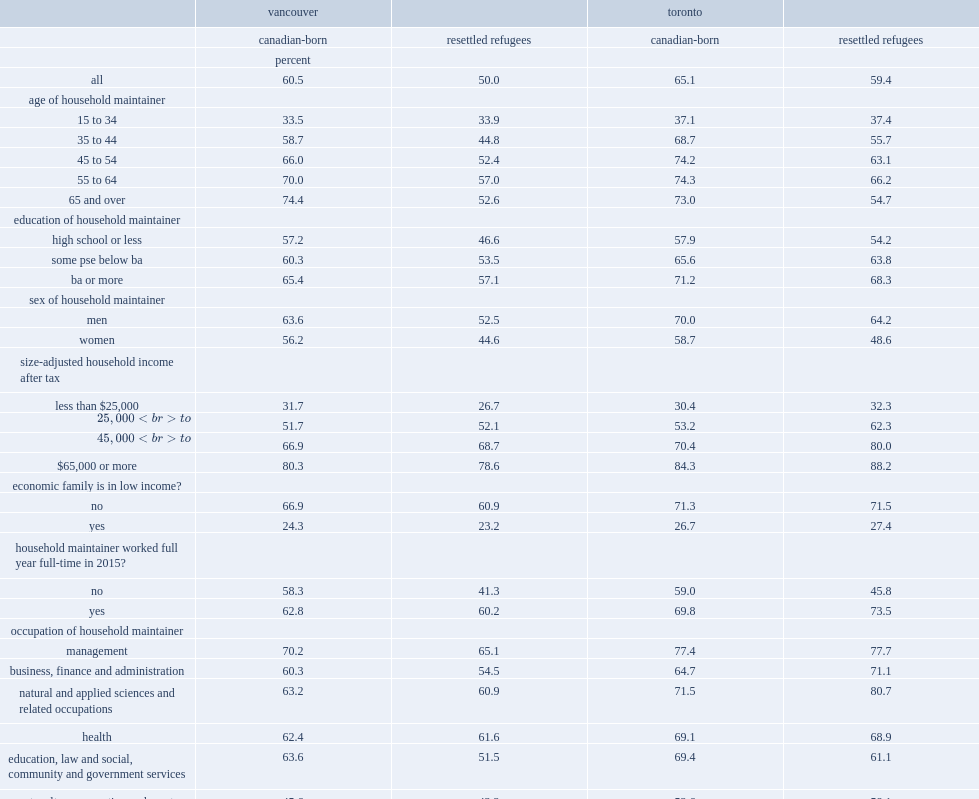Which group has the lower rates of homeownership in toronto, resettled refugee families or canadian-born families? Resettled refugees. Which group has the lower rates of homeownership in vancouver, resettled refugee families or canadian-born families? Resettled refugees. What was the percentage of refugee families that owned residential property in vancouver in 2016? 50. What was the percentage of canadian-born families that owned residential property in vancouver in 2016? 60.5. What was the percentage of refugee families that owned residential property in toronto in 2016? 59.4. What was the percentage of canadian-born families that owned residential property in toronto in 2016? 65.1. In toronto, which group has higher rates of homeownership with income level of less than $25,000, among refugee families or canadian-born families? Resettled refugees. In toronto, which group has higher rates of homeownership with income level of $25,000 to $44,999, among refugee families or canadian-born families? Resettled refugees. In toronto, which group has higher rates of homeownership with income level of $45,000 to $64,999, among refugee families or canadian-born families? Resettled refugees. In toronto, which group has higher rates of homeownership with income level of $65,000 or more, among refugee families or canadian-born families? Resettled refugees. 